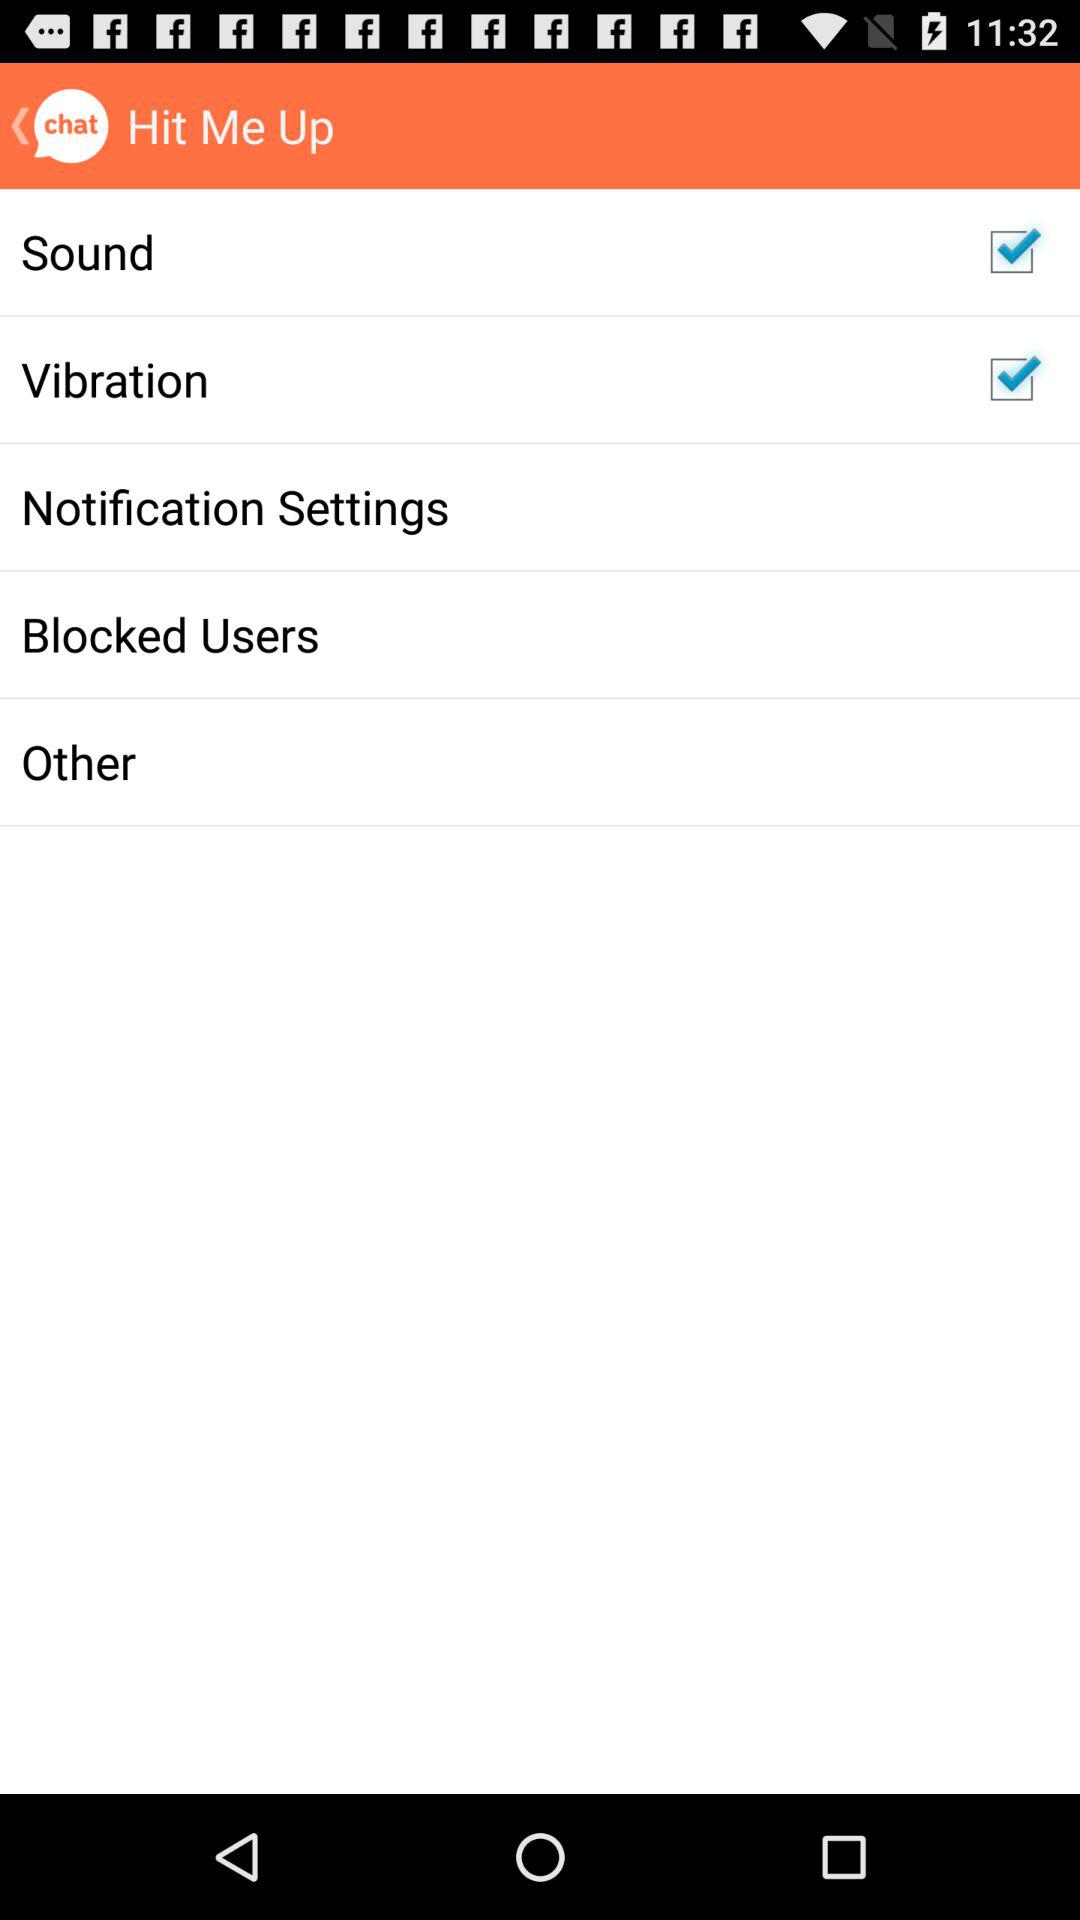What is the status of "Sound"? The status of "Sound" is "on". 